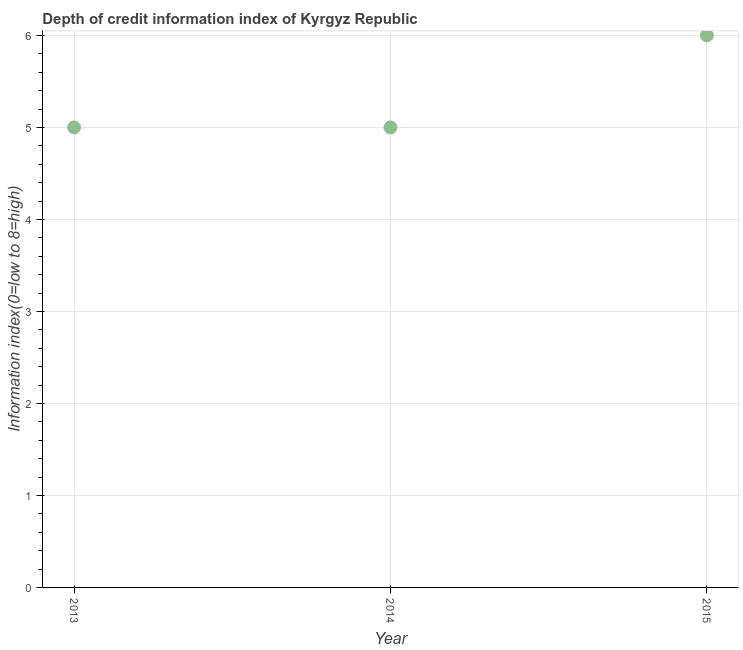What is the depth of credit information index in 2014?
Keep it short and to the point. 5. Across all years, what is the maximum depth of credit information index?
Keep it short and to the point. 6. Across all years, what is the minimum depth of credit information index?
Keep it short and to the point. 5. In which year was the depth of credit information index maximum?
Your answer should be very brief. 2015. In which year was the depth of credit information index minimum?
Your response must be concise. 2013. What is the sum of the depth of credit information index?
Your response must be concise. 16. What is the difference between the depth of credit information index in 2014 and 2015?
Make the answer very short. -1. What is the average depth of credit information index per year?
Keep it short and to the point. 5.33. What is the difference between the highest and the lowest depth of credit information index?
Provide a succinct answer. 1. In how many years, is the depth of credit information index greater than the average depth of credit information index taken over all years?
Give a very brief answer. 1. Does the depth of credit information index monotonically increase over the years?
Keep it short and to the point. No. How many dotlines are there?
Give a very brief answer. 1. Are the values on the major ticks of Y-axis written in scientific E-notation?
Make the answer very short. No. Does the graph contain any zero values?
Your answer should be compact. No. What is the title of the graph?
Your answer should be compact. Depth of credit information index of Kyrgyz Republic. What is the label or title of the X-axis?
Give a very brief answer. Year. What is the label or title of the Y-axis?
Your answer should be very brief. Information index(0=low to 8=high). What is the Information index(0=low to 8=high) in 2015?
Provide a succinct answer. 6. What is the difference between the Information index(0=low to 8=high) in 2013 and 2015?
Offer a terse response. -1. What is the difference between the Information index(0=low to 8=high) in 2014 and 2015?
Keep it short and to the point. -1. What is the ratio of the Information index(0=low to 8=high) in 2013 to that in 2015?
Give a very brief answer. 0.83. What is the ratio of the Information index(0=low to 8=high) in 2014 to that in 2015?
Provide a succinct answer. 0.83. 